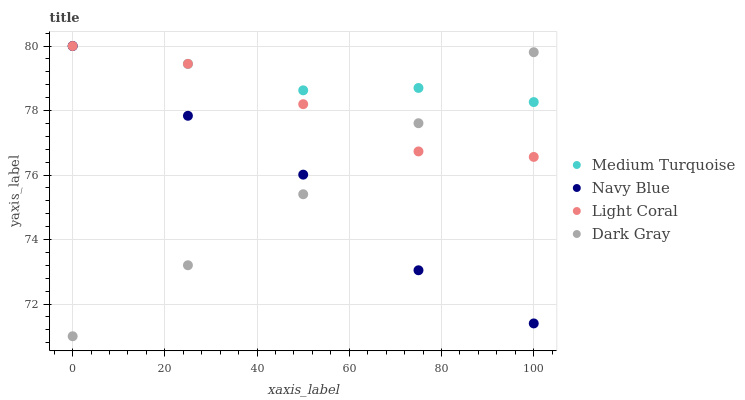Does Dark Gray have the minimum area under the curve?
Answer yes or no. Yes. Does Medium Turquoise have the maximum area under the curve?
Answer yes or no. Yes. Does Navy Blue have the minimum area under the curve?
Answer yes or no. No. Does Navy Blue have the maximum area under the curve?
Answer yes or no. No. Is Dark Gray the smoothest?
Answer yes or no. Yes. Is Navy Blue the roughest?
Answer yes or no. Yes. Is Navy Blue the smoothest?
Answer yes or no. No. Is Dark Gray the roughest?
Answer yes or no. No. Does Dark Gray have the lowest value?
Answer yes or no. Yes. Does Navy Blue have the lowest value?
Answer yes or no. No. Does Medium Turquoise have the highest value?
Answer yes or no. Yes. Does Dark Gray have the highest value?
Answer yes or no. No. Does Light Coral intersect Dark Gray?
Answer yes or no. Yes. Is Light Coral less than Dark Gray?
Answer yes or no. No. Is Light Coral greater than Dark Gray?
Answer yes or no. No. 